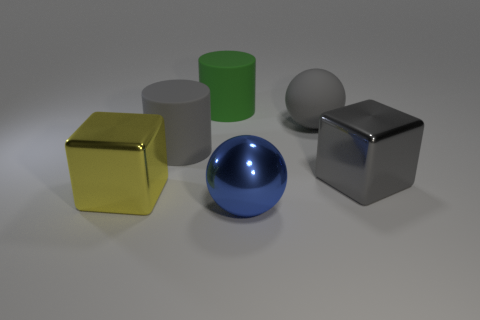Are there any big metal things of the same color as the large rubber ball?
Ensure brevity in your answer.  Yes. The large matte thing that is the same color as the large rubber sphere is what shape?
Offer a very short reply. Cylinder. Is there another matte cylinder of the same size as the green cylinder?
Provide a short and direct response. Yes. There is a large yellow cube that is left of the sphere that is right of the big blue sphere that is on the left side of the big gray rubber sphere; what is it made of?
Ensure brevity in your answer.  Metal. What number of large metal cubes are behind the large metal cube that is right of the rubber ball?
Your response must be concise. 0. Do the rubber cylinder to the left of the green cylinder and the gray rubber sphere have the same size?
Make the answer very short. Yes. How many big gray rubber things have the same shape as the green object?
Your response must be concise. 1. What shape is the yellow shiny thing?
Offer a very short reply. Cube. Is the number of gray matte objects that are right of the big gray rubber cylinder the same as the number of cyan metallic cylinders?
Offer a terse response. No. Are there any other things that are made of the same material as the big blue object?
Give a very brief answer. Yes. 